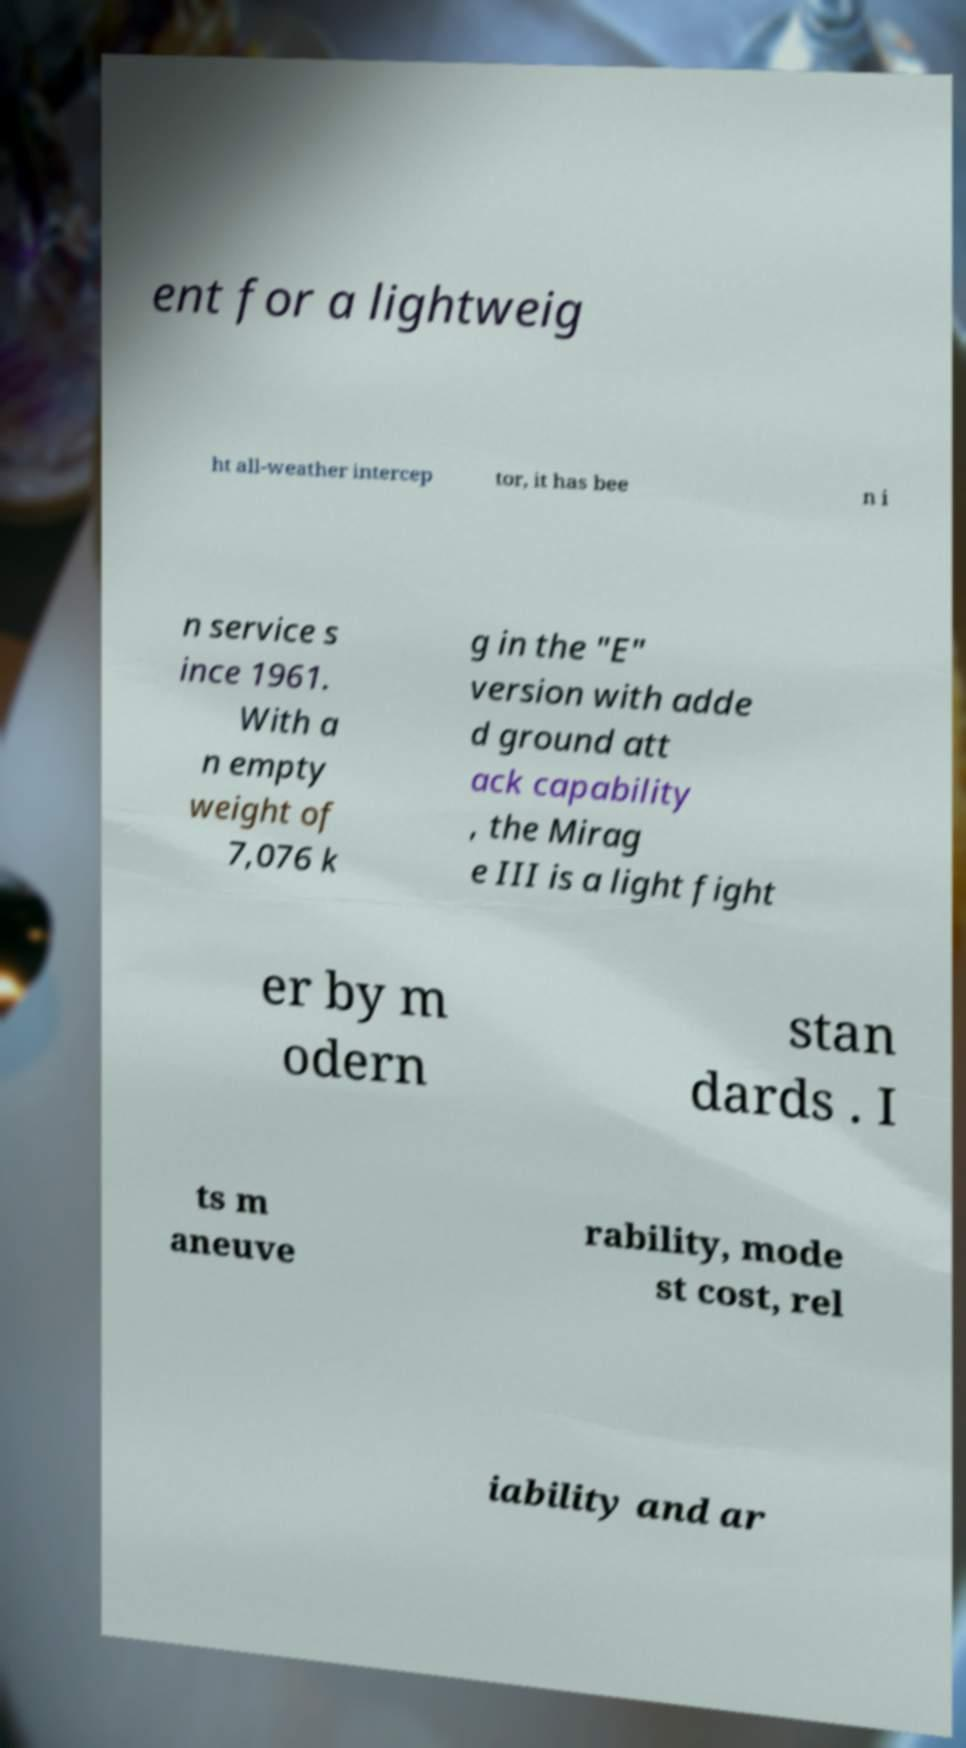For documentation purposes, I need the text within this image transcribed. Could you provide that? ent for a lightweig ht all-weather intercep tor, it has bee n i n service s ince 1961. With a n empty weight of 7,076 k g in the "E" version with adde d ground att ack capability , the Mirag e III is a light fight er by m odern stan dards . I ts m aneuve rability, mode st cost, rel iability and ar 